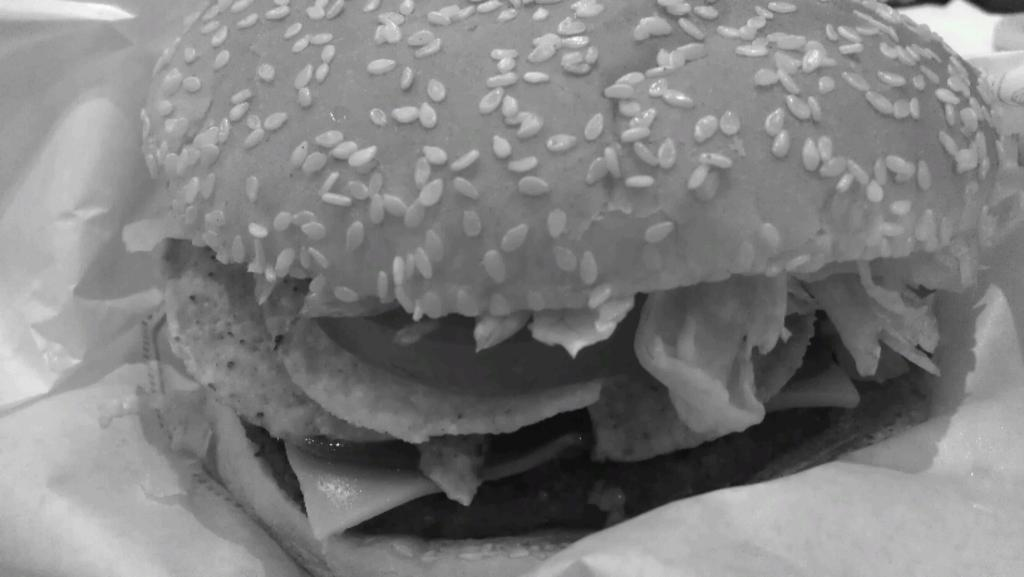What type of food is visible in the image? The food appears to be a burger. What is the color scheme of the image? The image is black and white. What language is spoken by the burger in the image? The burger does not speak a language, as it is an inanimate object. 